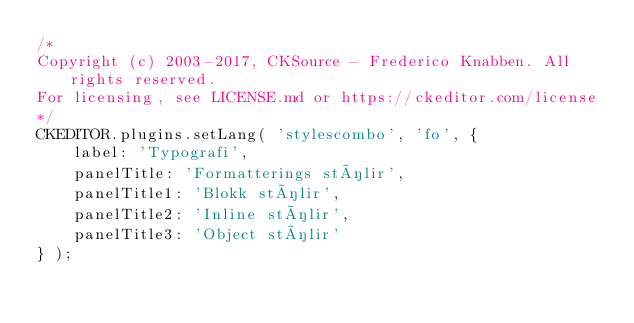<code> <loc_0><loc_0><loc_500><loc_500><_JavaScript_>/*
Copyright (c) 2003-2017, CKSource - Frederico Knabben. All rights reserved.
For licensing, see LICENSE.md or https://ckeditor.com/license
*/
CKEDITOR.plugins.setLang( 'stylescombo', 'fo', {
	label: 'Typografi',
	panelTitle: 'Formatterings stílir',
	panelTitle1: 'Blokk stílir',
	panelTitle2: 'Inline stílir',
	panelTitle3: 'Object stílir'
} );
</code> 